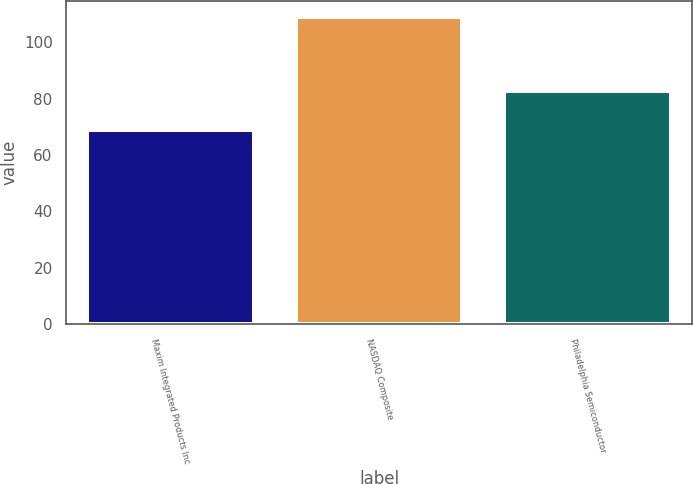Convert chart to OTSL. <chart><loc_0><loc_0><loc_500><loc_500><bar_chart><fcel>Maxim Integrated Products Inc<fcel>NASDAQ Composite<fcel>Philadelphia Semiconductor<nl><fcel>68.8<fcel>109.15<fcel>82.87<nl></chart> 